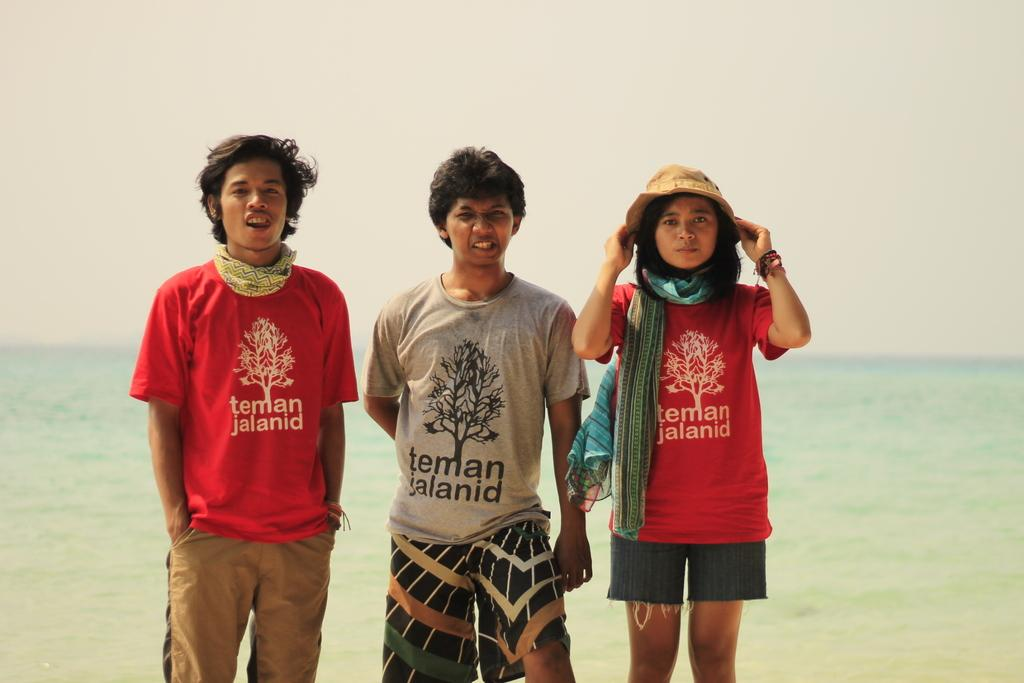How many people are in the image? There are three people in the image. Where are the people located in relation to the image? The people are standing in the foreground. What can be seen in the background of the image? There is a beach visible in the background of the image. What type of cable can be seen connecting the people in the image? There is no cable connecting the people in the image. What tool is being used by the people to dig in the sand in the image? The provided facts do not mention any tools being used by the people in the image. 